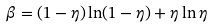<formula> <loc_0><loc_0><loc_500><loc_500>\beta = ( 1 - \eta ) \ln ( 1 - \eta ) + \eta \ln \eta</formula> 